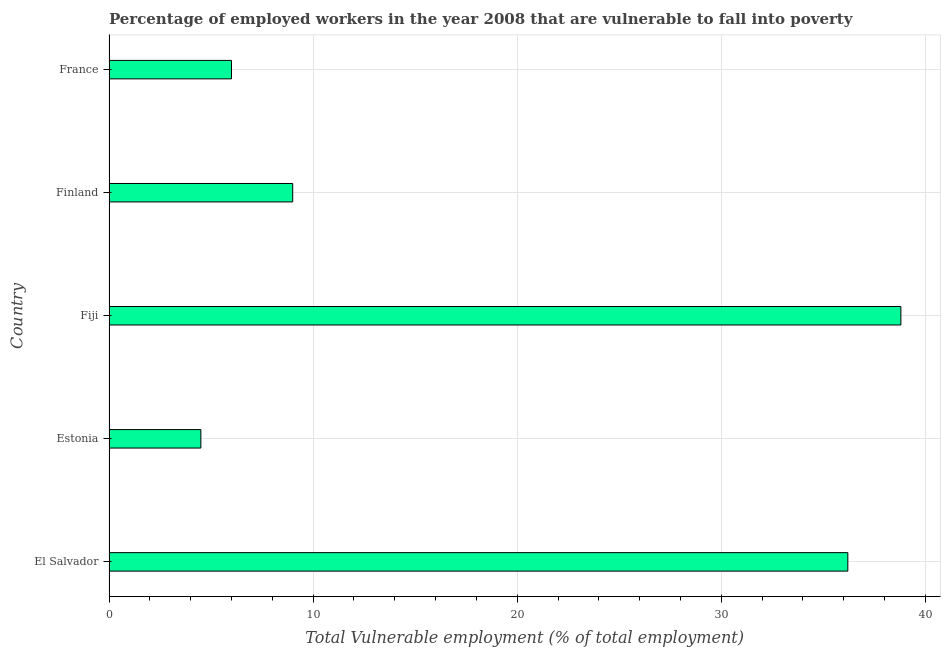Does the graph contain any zero values?
Ensure brevity in your answer.  No. What is the title of the graph?
Offer a very short reply. Percentage of employed workers in the year 2008 that are vulnerable to fall into poverty. What is the label or title of the X-axis?
Provide a succinct answer. Total Vulnerable employment (% of total employment). What is the total vulnerable employment in France?
Your answer should be very brief. 6. Across all countries, what is the maximum total vulnerable employment?
Provide a short and direct response. 38.8. In which country was the total vulnerable employment maximum?
Your answer should be compact. Fiji. In which country was the total vulnerable employment minimum?
Make the answer very short. Estonia. What is the sum of the total vulnerable employment?
Provide a short and direct response. 94.5. What is the difference between the total vulnerable employment in El Salvador and Estonia?
Your answer should be compact. 31.7. What is the median total vulnerable employment?
Offer a very short reply. 9. What is the ratio of the total vulnerable employment in El Salvador to that in Estonia?
Ensure brevity in your answer.  8.04. Is the total vulnerable employment in Fiji less than that in Finland?
Offer a very short reply. No. Is the difference between the total vulnerable employment in Fiji and Finland greater than the difference between any two countries?
Your answer should be compact. No. What is the difference between the highest and the second highest total vulnerable employment?
Keep it short and to the point. 2.6. Is the sum of the total vulnerable employment in El Salvador and Estonia greater than the maximum total vulnerable employment across all countries?
Give a very brief answer. Yes. What is the difference between the highest and the lowest total vulnerable employment?
Offer a terse response. 34.3. Are all the bars in the graph horizontal?
Make the answer very short. Yes. How many countries are there in the graph?
Offer a very short reply. 5. What is the Total Vulnerable employment (% of total employment) of El Salvador?
Your response must be concise. 36.2. What is the Total Vulnerable employment (% of total employment) of Fiji?
Ensure brevity in your answer.  38.8. What is the Total Vulnerable employment (% of total employment) in Finland?
Make the answer very short. 9. What is the difference between the Total Vulnerable employment (% of total employment) in El Salvador and Estonia?
Ensure brevity in your answer.  31.7. What is the difference between the Total Vulnerable employment (% of total employment) in El Salvador and Fiji?
Make the answer very short. -2.6. What is the difference between the Total Vulnerable employment (% of total employment) in El Salvador and Finland?
Your response must be concise. 27.2. What is the difference between the Total Vulnerable employment (% of total employment) in El Salvador and France?
Make the answer very short. 30.2. What is the difference between the Total Vulnerable employment (% of total employment) in Estonia and Fiji?
Offer a very short reply. -34.3. What is the difference between the Total Vulnerable employment (% of total employment) in Estonia and Finland?
Ensure brevity in your answer.  -4.5. What is the difference between the Total Vulnerable employment (% of total employment) in Fiji and Finland?
Provide a short and direct response. 29.8. What is the difference between the Total Vulnerable employment (% of total employment) in Fiji and France?
Give a very brief answer. 32.8. What is the difference between the Total Vulnerable employment (% of total employment) in Finland and France?
Your response must be concise. 3. What is the ratio of the Total Vulnerable employment (% of total employment) in El Salvador to that in Estonia?
Provide a short and direct response. 8.04. What is the ratio of the Total Vulnerable employment (% of total employment) in El Salvador to that in Fiji?
Offer a very short reply. 0.93. What is the ratio of the Total Vulnerable employment (% of total employment) in El Salvador to that in Finland?
Ensure brevity in your answer.  4.02. What is the ratio of the Total Vulnerable employment (% of total employment) in El Salvador to that in France?
Ensure brevity in your answer.  6.03. What is the ratio of the Total Vulnerable employment (% of total employment) in Estonia to that in Fiji?
Give a very brief answer. 0.12. What is the ratio of the Total Vulnerable employment (% of total employment) in Estonia to that in Finland?
Ensure brevity in your answer.  0.5. What is the ratio of the Total Vulnerable employment (% of total employment) in Fiji to that in Finland?
Keep it short and to the point. 4.31. What is the ratio of the Total Vulnerable employment (% of total employment) in Fiji to that in France?
Offer a terse response. 6.47. What is the ratio of the Total Vulnerable employment (% of total employment) in Finland to that in France?
Your answer should be very brief. 1.5. 